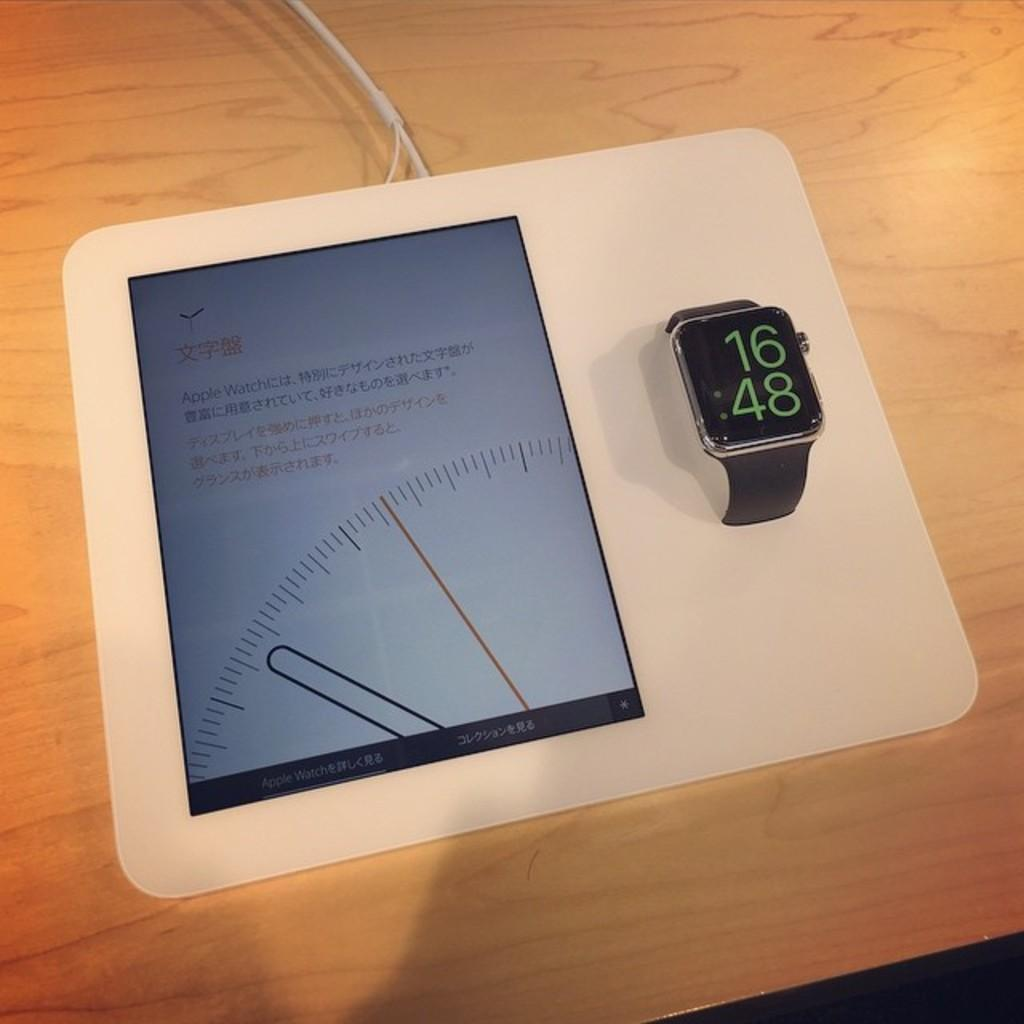Provide a one-sentence caption for the provided image. An Apple Watch displays a time of 16:48 on its dark black face. 